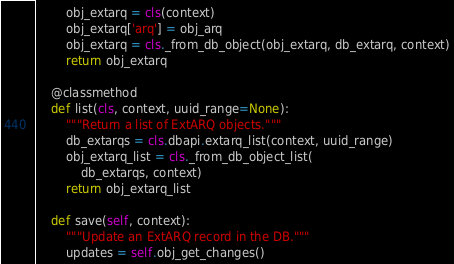Convert code to text. <code><loc_0><loc_0><loc_500><loc_500><_Python_>        obj_extarq = cls(context)
        obj_extarq['arq'] = obj_arq
        obj_extarq = cls._from_db_object(obj_extarq, db_extarq, context)
        return obj_extarq

    @classmethod
    def list(cls, context, uuid_range=None):
        """Return a list of ExtARQ objects."""
        db_extarqs = cls.dbapi.extarq_list(context, uuid_range)
        obj_extarq_list = cls._from_db_object_list(
            db_extarqs, context)
        return obj_extarq_list

    def save(self, context):
        """Update an ExtARQ record in the DB."""
        updates = self.obj_get_changes()</code> 